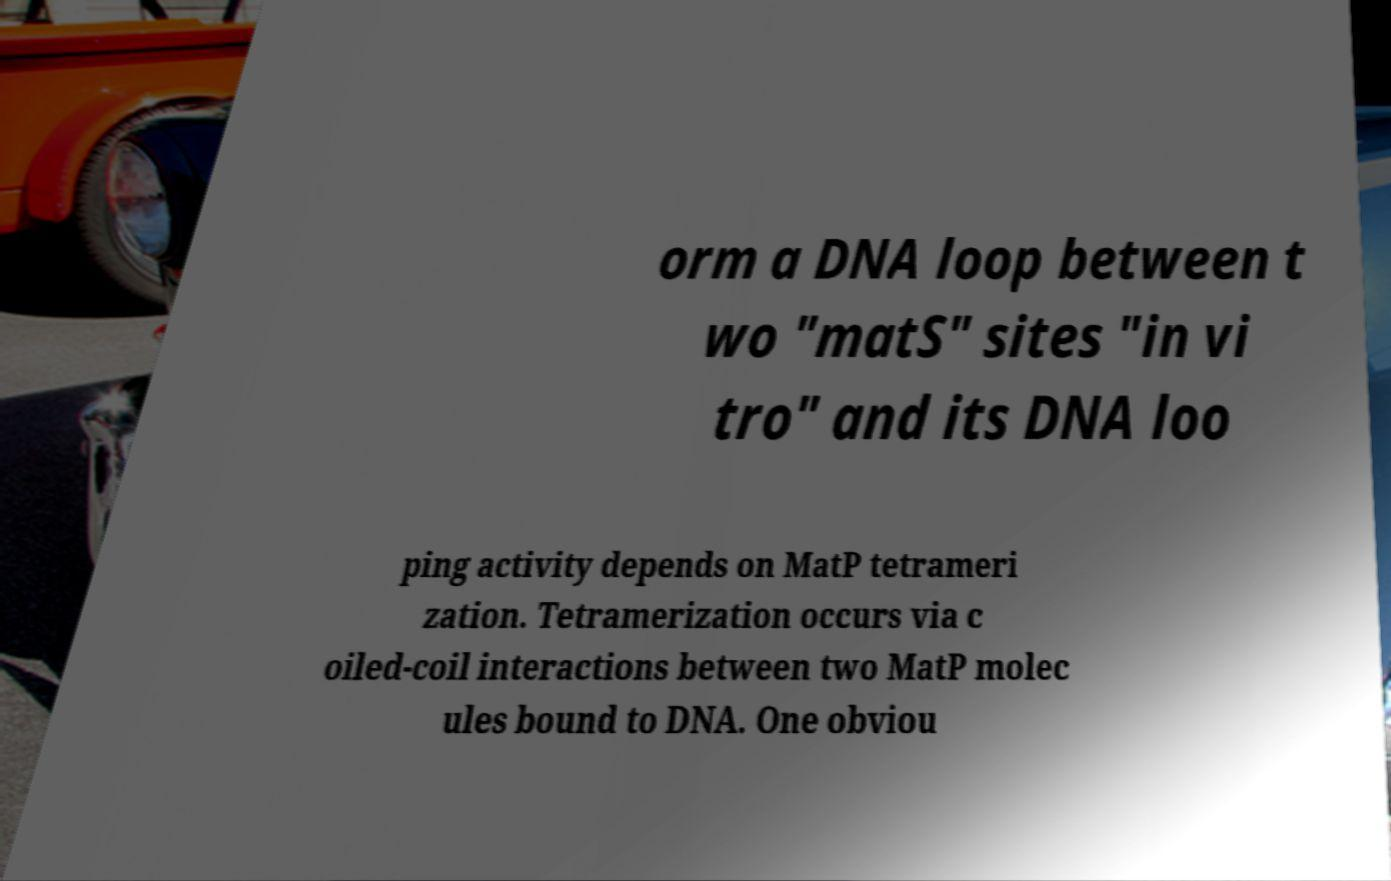Please identify and transcribe the text found in this image. orm a DNA loop between t wo "matS" sites "in vi tro" and its DNA loo ping activity depends on MatP tetrameri zation. Tetramerization occurs via c oiled-coil interactions between two MatP molec ules bound to DNA. One obviou 